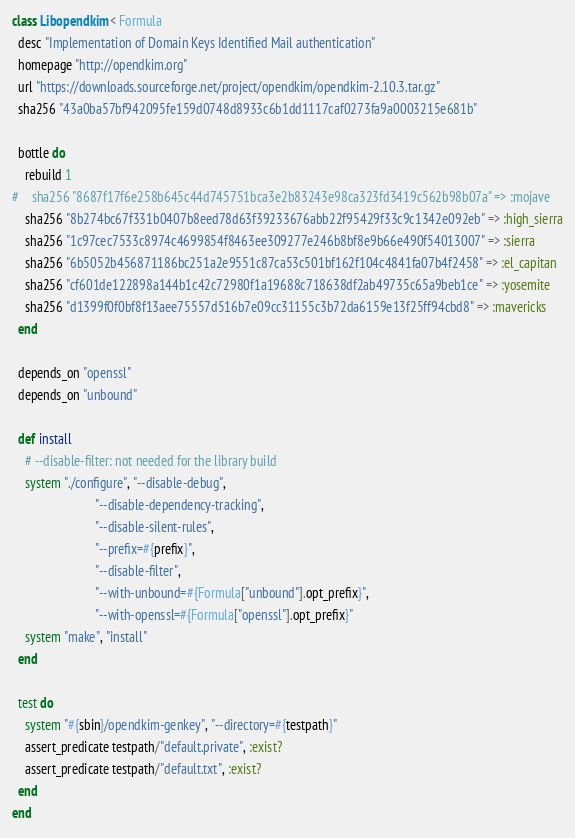<code> <loc_0><loc_0><loc_500><loc_500><_Ruby_>class Libopendkim < Formula
  desc "Implementation of Domain Keys Identified Mail authentication"
  homepage "http://opendkim.org"
  url "https://downloads.sourceforge.net/project/opendkim/opendkim-2.10.3.tar.gz"
  sha256 "43a0ba57bf942095fe159d0748d8933c6b1dd1117caf0273fa9a0003215e681b"

  bottle do
    rebuild 1
#    sha256 "8687f17f6e258b645c44d745751bca3e2b83243e98ca323fd3419c562b98b07a" => :mojave
    sha256 "8b274bc67f331b0407b8eed78d63f39233676abb22f95429f33c9c1342e092eb" => :high_sierra
    sha256 "1c97cec7533c8974c4699854f8463ee309277e246b8bf8e9b66e490f54013007" => :sierra
    sha256 "6b5052b456871186bc251a2e9551c87ca53c501bf162f104c4841fa07b4f2458" => :el_capitan
    sha256 "cf601de122898a144b1c42c72980f1a19688c718638df2ab49735c65a9beb1ce" => :yosemite
    sha256 "d1399f0f0bf8f13aee75557d516b7e09cc31155c3b72da6159e13f25ff94cbd8" => :mavericks
  end

  depends_on "openssl"
  depends_on "unbound"

  def install
    # --disable-filter: not needed for the library build
    system "./configure", "--disable-debug",
                          "--disable-dependency-tracking",
                          "--disable-silent-rules",
                          "--prefix=#{prefix}",
                          "--disable-filter",
                          "--with-unbound=#{Formula["unbound"].opt_prefix}",
                          "--with-openssl=#{Formula["openssl"].opt_prefix}"
    system "make", "install"
  end

  test do
    system "#{sbin}/opendkim-genkey", "--directory=#{testpath}"
    assert_predicate testpath/"default.private", :exist?
    assert_predicate testpath/"default.txt", :exist?
  end
end
</code> 